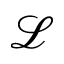Convert formula to latex. <formula><loc_0><loc_0><loc_500><loc_500>\ m a t h s c r { L }</formula> 